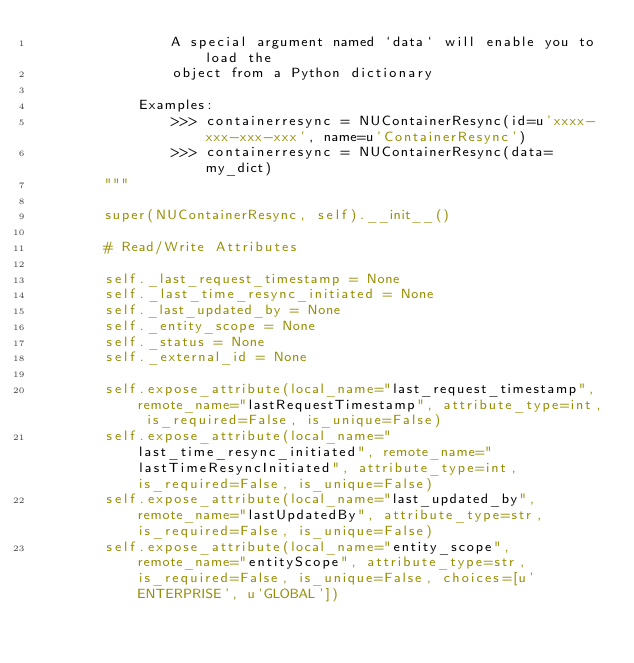<code> <loc_0><loc_0><loc_500><loc_500><_Python_>                A special argument named `data` will enable you to load the
                object from a Python dictionary

            Examples:
                >>> containerresync = NUContainerResync(id=u'xxxx-xxx-xxx-xxx', name=u'ContainerResync')
                >>> containerresync = NUContainerResync(data=my_dict)
        """

        super(NUContainerResync, self).__init__()

        # Read/Write Attributes
        
        self._last_request_timestamp = None
        self._last_time_resync_initiated = None
        self._last_updated_by = None
        self._entity_scope = None
        self._status = None
        self._external_id = None
        
        self.expose_attribute(local_name="last_request_timestamp", remote_name="lastRequestTimestamp", attribute_type=int, is_required=False, is_unique=False)
        self.expose_attribute(local_name="last_time_resync_initiated", remote_name="lastTimeResyncInitiated", attribute_type=int, is_required=False, is_unique=False)
        self.expose_attribute(local_name="last_updated_by", remote_name="lastUpdatedBy", attribute_type=str, is_required=False, is_unique=False)
        self.expose_attribute(local_name="entity_scope", remote_name="entityScope", attribute_type=str, is_required=False, is_unique=False, choices=[u'ENTERPRISE', u'GLOBAL'])</code> 